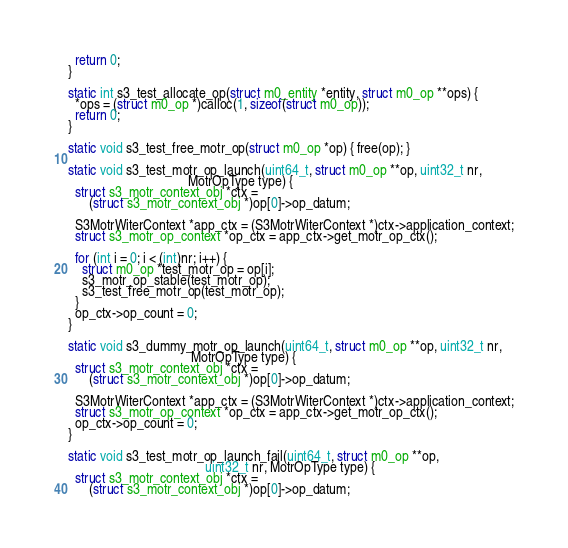<code> <loc_0><loc_0><loc_500><loc_500><_C++_>  return 0;
}

static int s3_test_allocate_op(struct m0_entity *entity, struct m0_op **ops) {
  *ops = (struct m0_op *)calloc(1, sizeof(struct m0_op));
  return 0;
}

static void s3_test_free_motr_op(struct m0_op *op) { free(op); }

static void s3_test_motr_op_launch(uint64_t, struct m0_op **op, uint32_t nr,
                                   MotrOpType type) {
  struct s3_motr_context_obj *ctx =
      (struct s3_motr_context_obj *)op[0]->op_datum;

  S3MotrWiterContext *app_ctx = (S3MotrWiterContext *)ctx->application_context;
  struct s3_motr_op_context *op_ctx = app_ctx->get_motr_op_ctx();

  for (int i = 0; i < (int)nr; i++) {
    struct m0_op *test_motr_op = op[i];
    s3_motr_op_stable(test_motr_op);
    s3_test_free_motr_op(test_motr_op);
  }
  op_ctx->op_count = 0;
}

static void s3_dummy_motr_op_launch(uint64_t, struct m0_op **op, uint32_t nr,
                                    MotrOpType type) {
  struct s3_motr_context_obj *ctx =
      (struct s3_motr_context_obj *)op[0]->op_datum;

  S3MotrWiterContext *app_ctx = (S3MotrWiterContext *)ctx->application_context;
  struct s3_motr_op_context *op_ctx = app_ctx->get_motr_op_ctx();
  op_ctx->op_count = 0;
}

static void s3_test_motr_op_launch_fail(uint64_t, struct m0_op **op,
                                        uint32_t nr, MotrOpType type) {
  struct s3_motr_context_obj *ctx =
      (struct s3_motr_context_obj *)op[0]->op_datum;
</code> 